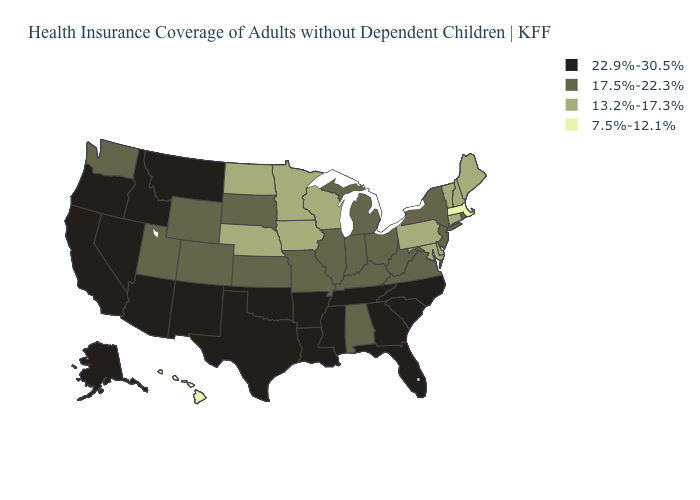What is the lowest value in states that border North Carolina?
Concise answer only. 17.5%-22.3%. Which states have the lowest value in the West?
Answer briefly. Hawaii. Does the map have missing data?
Concise answer only. No. What is the highest value in the USA?
Be succinct. 22.9%-30.5%. What is the value of Illinois?
Answer briefly. 17.5%-22.3%. Does Kentucky have a lower value than Michigan?
Answer briefly. No. Does Oklahoma have a higher value than South Carolina?
Quick response, please. No. What is the value of Pennsylvania?
Give a very brief answer. 13.2%-17.3%. Among the states that border Texas , which have the lowest value?
Give a very brief answer. Arkansas, Louisiana, New Mexico, Oklahoma. What is the lowest value in the USA?
Quick response, please. 7.5%-12.1%. What is the lowest value in the Northeast?
Give a very brief answer. 7.5%-12.1%. Which states have the lowest value in the USA?
Write a very short answer. Hawaii, Massachusetts. What is the lowest value in the USA?
Short answer required. 7.5%-12.1%. What is the value of New Mexico?
Answer briefly. 22.9%-30.5%. Name the states that have a value in the range 7.5%-12.1%?
Quick response, please. Hawaii, Massachusetts. 